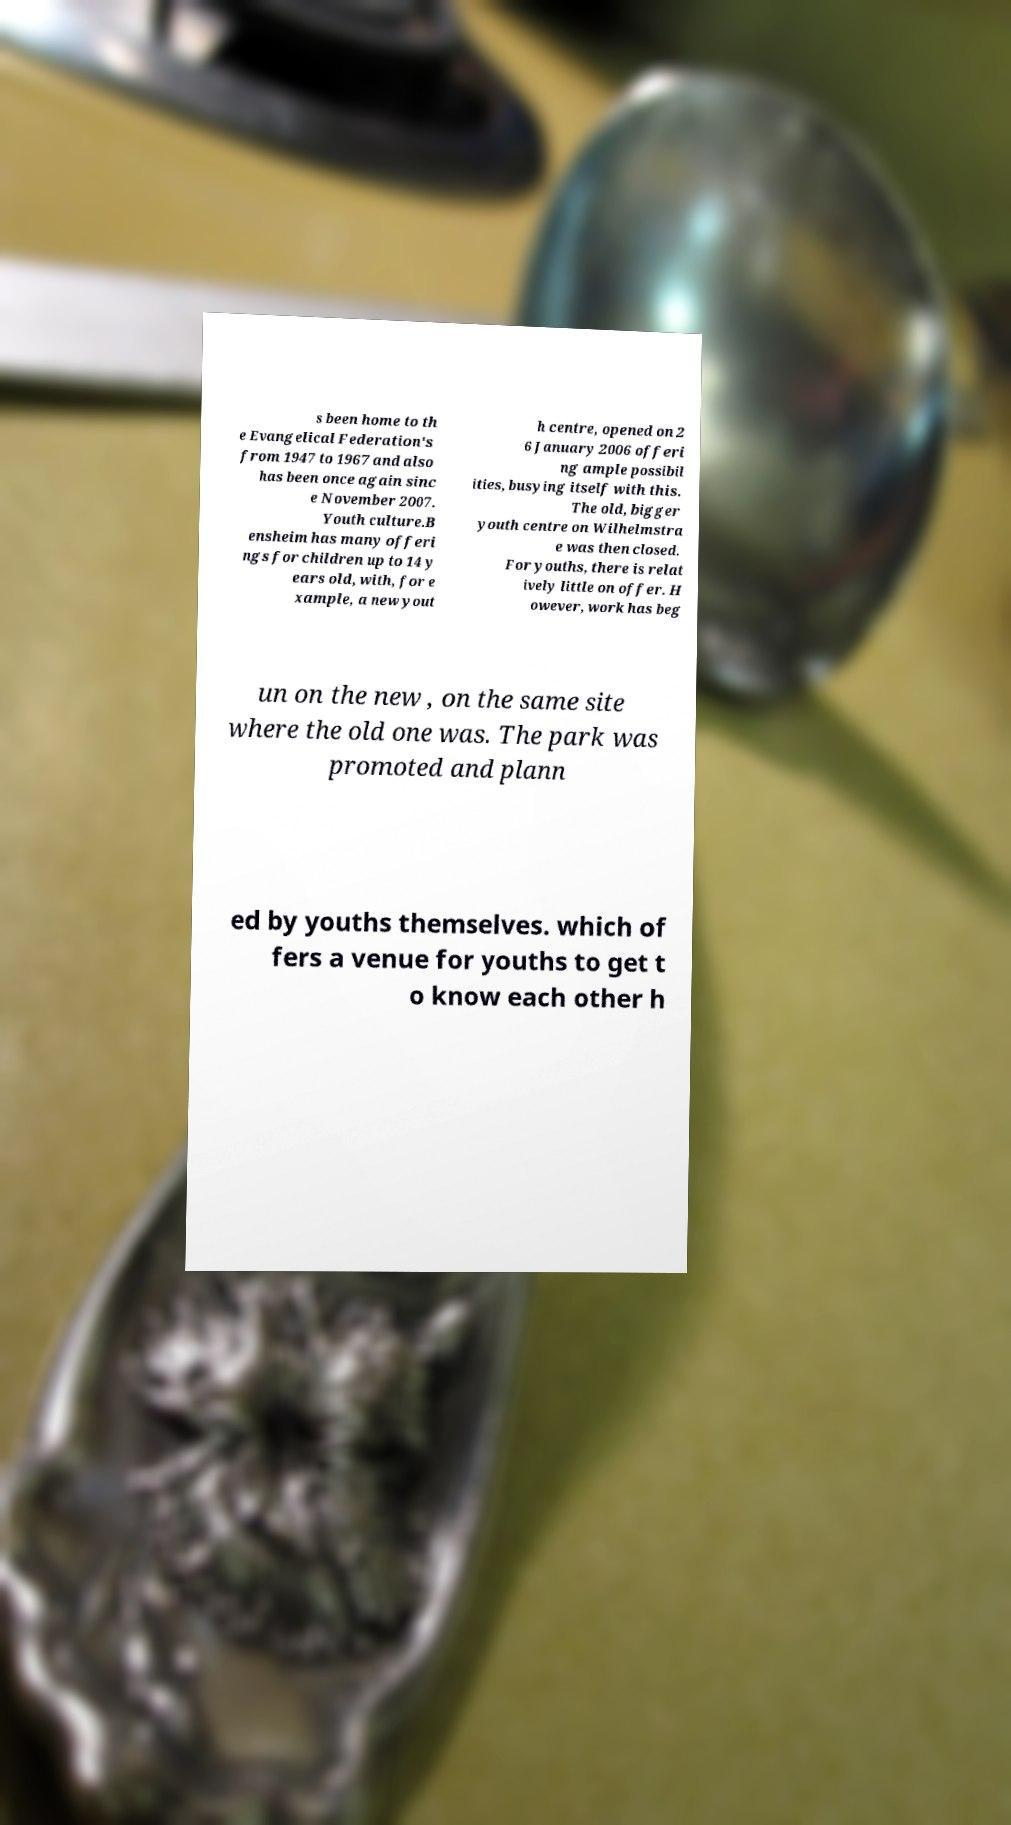Please identify and transcribe the text found in this image. s been home to th e Evangelical Federation's from 1947 to 1967 and also has been once again sinc e November 2007. Youth culture.B ensheim has many offeri ngs for children up to 14 y ears old, with, for e xample, a new yout h centre, opened on 2 6 January 2006 offeri ng ample possibil ities, busying itself with this. The old, bigger youth centre on Wilhelmstra e was then closed. For youths, there is relat ively little on offer. H owever, work has beg un on the new , on the same site where the old one was. The park was promoted and plann ed by youths themselves. which of fers a venue for youths to get t o know each other h 